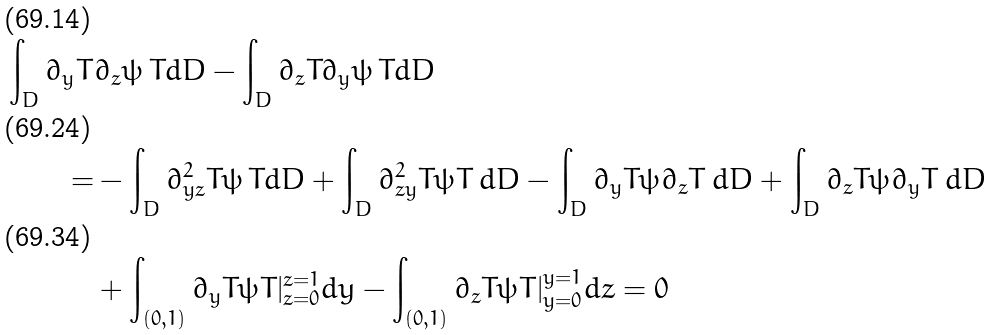<formula> <loc_0><loc_0><loc_500><loc_500>\int _ { D } \partial _ { y } T & \partial _ { z } \psi \, T d D - \int _ { D } \partial _ { z } T \partial _ { y } \psi \, T d D \\ = & - \int _ { D } \partial _ { y z } ^ { 2 } T \psi \, T d D + \int _ { D } \partial _ { z y } ^ { 2 } T \psi T \, d D - \int _ { D } \partial _ { y } T \psi \partial _ { z } T \, d D + \int _ { D } \partial _ { z } T \psi \partial _ { y } T \, d D \\ & + \int _ { ( 0 , 1 ) } \partial _ { y } T \psi T | _ { z = 0 } ^ { z = 1 } d y - \int _ { ( 0 , 1 ) } \partial _ { z } T \psi T | _ { y = 0 } ^ { y = 1 } d z = 0</formula> 